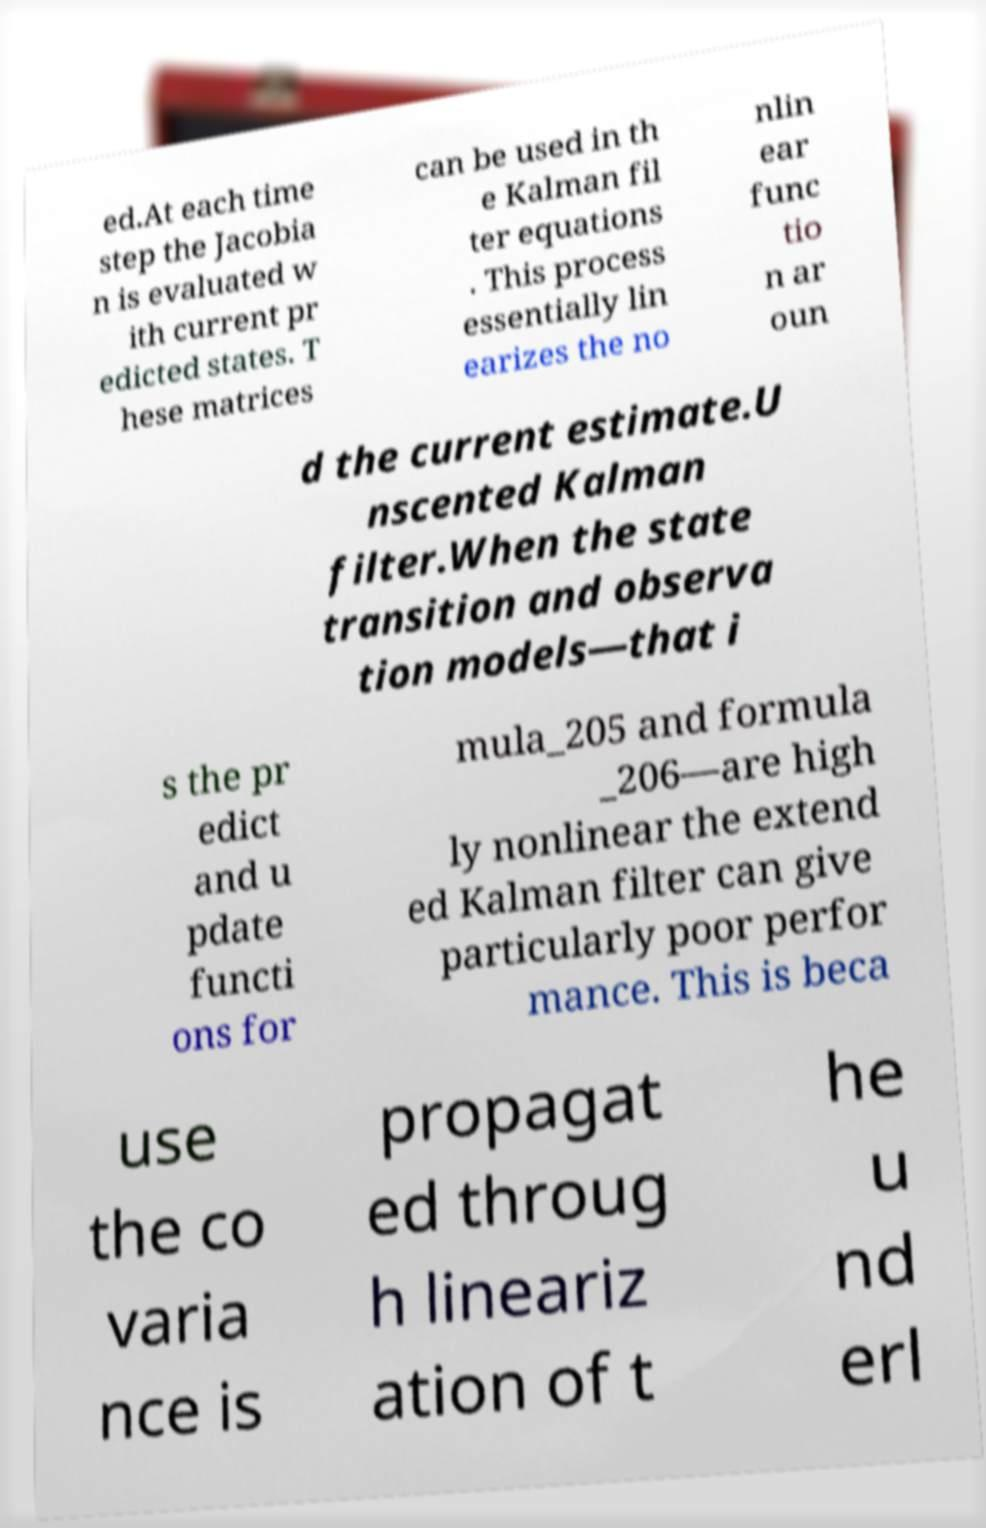Please read and relay the text visible in this image. What does it say? ed.At each time step the Jacobia n is evaluated w ith current pr edicted states. T hese matrices can be used in th e Kalman fil ter equations . This process essentially lin earizes the no nlin ear func tio n ar oun d the current estimate.U nscented Kalman filter.When the state transition and observa tion models—that i s the pr edict and u pdate functi ons for mula_205 and formula _206—are high ly nonlinear the extend ed Kalman filter can give particularly poor perfor mance. This is beca use the co varia nce is propagat ed throug h lineariz ation of t he u nd erl 